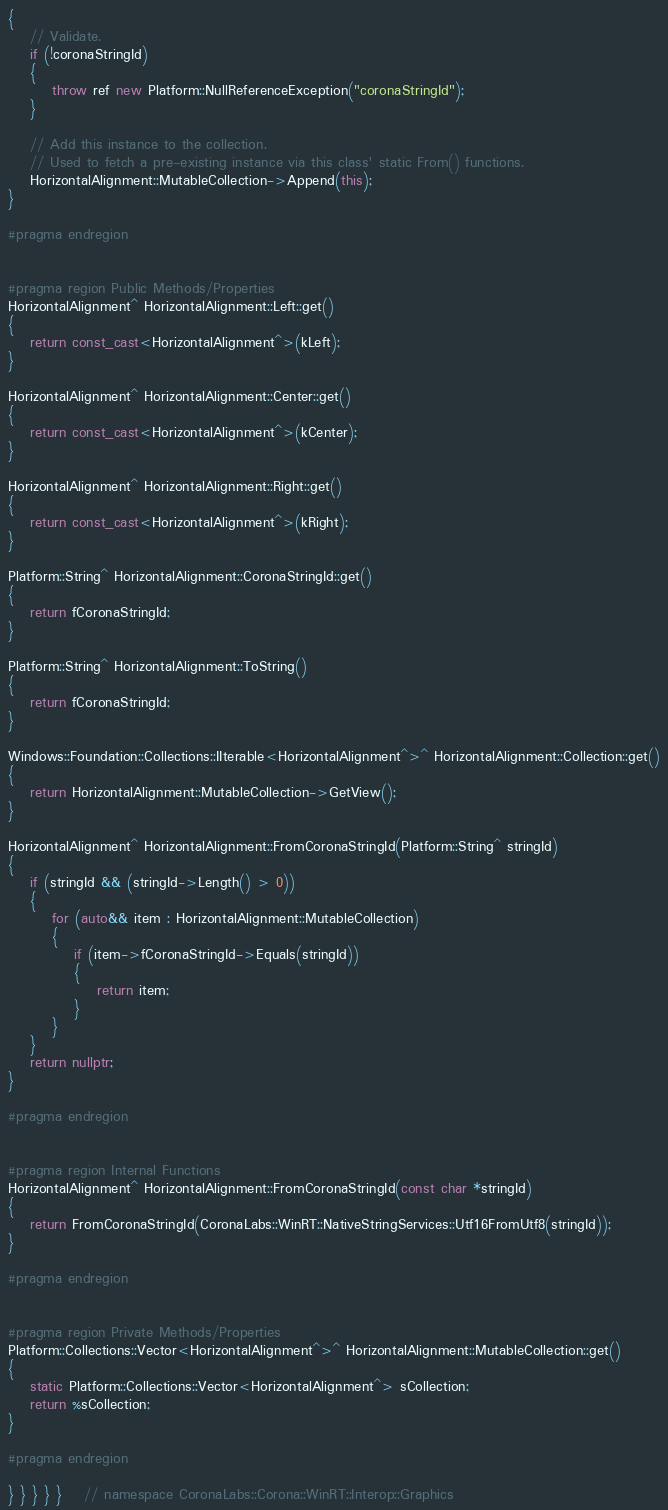<code> <loc_0><loc_0><loc_500><loc_500><_C++_>{
	// Validate.
	if (!coronaStringId)
	{
		throw ref new Platform::NullReferenceException("coronaStringId");
	}

	// Add this instance to the collection.
	// Used to fetch a pre-existing instance via this class' static From() functions.
	HorizontalAlignment::MutableCollection->Append(this);
}

#pragma endregion


#pragma region Public Methods/Properties
HorizontalAlignment^ HorizontalAlignment::Left::get()
{
	return const_cast<HorizontalAlignment^>(kLeft);
}

HorizontalAlignment^ HorizontalAlignment::Center::get()
{
	return const_cast<HorizontalAlignment^>(kCenter);
}

HorizontalAlignment^ HorizontalAlignment::Right::get()
{
	return const_cast<HorizontalAlignment^>(kRight);
}

Platform::String^ HorizontalAlignment::CoronaStringId::get()
{
	return fCoronaStringId;
}

Platform::String^ HorizontalAlignment::ToString()
{
	return fCoronaStringId;
}

Windows::Foundation::Collections::IIterable<HorizontalAlignment^>^ HorizontalAlignment::Collection::get()
{
	return HorizontalAlignment::MutableCollection->GetView();
}

HorizontalAlignment^ HorizontalAlignment::FromCoronaStringId(Platform::String^ stringId)
{
	if (stringId && (stringId->Length() > 0))
	{
		for (auto&& item : HorizontalAlignment::MutableCollection)
		{
			if (item->fCoronaStringId->Equals(stringId))
			{
				return item;
			}
		}
	}
	return nullptr;
}

#pragma endregion


#pragma region Internal Functions
HorizontalAlignment^ HorizontalAlignment::FromCoronaStringId(const char *stringId)
{
	return FromCoronaStringId(CoronaLabs::WinRT::NativeStringServices::Utf16FromUtf8(stringId));
}

#pragma endregion


#pragma region Private Methods/Properties
Platform::Collections::Vector<HorizontalAlignment^>^ HorizontalAlignment::MutableCollection::get()
{
	static Platform::Collections::Vector<HorizontalAlignment^> sCollection;
	return %sCollection;
}

#pragma endregion

} } } } }	// namespace CoronaLabs::Corona::WinRT::Interop::Graphics
</code> 